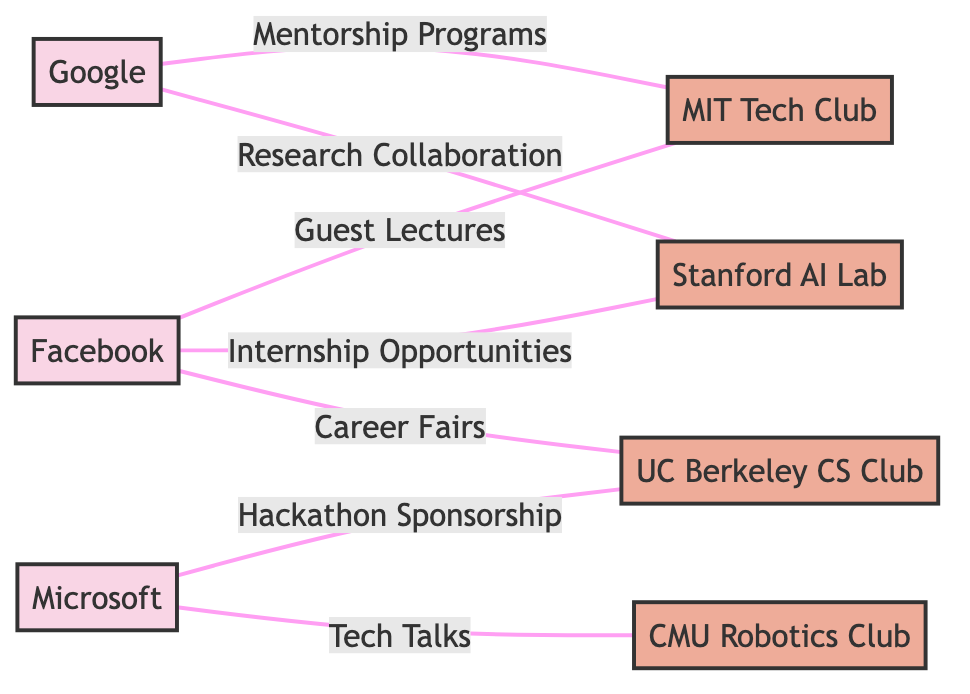What are the major tech firms represented in the diagram? The diagram lists three major tech firms: Google, Microsoft, and Facebook. These are all shown as nodes representing the firms.
Answer: Google, Microsoft, Facebook How many university tech clubs are included in the graph? There are four university tech clubs shown in the diagram: MIT Tech Club, Stanford AI Lab, UC Berkeley CS Club, and CMU Robotics Club, which are represented as nodes.
Answer: 4 What type of interaction does Google have with the MIT Tech Club? The diagram indicates that Google participates in "Mentorship Programs" with the MIT Tech Club, represented by an edge connecting the two nodes labeled as such.
Answer: Mentorship Programs Which tech firm sponsors a hackathon according to the diagram? From the diagram, Microsoft is shown to sponsor a "Hackathon" for the UC Berkeley CS Club, as indicated by the edge labeled with this interaction.
Answer: Microsoft How many interactions does Facebook have with university tech clubs in total? By examining the edges connecting Facebook to the university tech clubs, we can see three interactions: Guest Lectures with MIT Tech Club, Internship Opportunities with Stanford AI Lab, and Career Fairs with UC Berkeley CS Club, totaling three interactions.
Answer: 3 Which university tech club has collaborations with both Google and Facebook? The MIT Tech Club is the only club that collaborates with both Google (through Mentorship Programs) and Facebook (through Guest Lectures), making it unique in this regard based on the edges in the diagram.
Answer: MIT Tech Club Which tech firm has more interactions with university tech clubs, Microsoft or Facebook? By counting, Microsoft has two interactions (Hackathon Sponsorship and Tech Talks), while Facebook also has three interactions (Guest Lectures, Internship Opportunities, and Career Fairs), thus making Facebook the tech firm with more interactions.
Answer: Facebook What is the interaction type between Microsoft and the CMU Robotics Club? The connection between Microsoft and the CMU Robotics Club is labeled with the interaction "Tech Talks," which describes the nature of their relationship in the diagram.
Answer: Tech Talks How many total edges connect tech firms to university tech clubs in the graph? The total number of edges connecting the tech firms to the university tech clubs can be counted as follows: there are seven edges represented in the diagram.
Answer: 7 